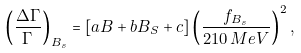Convert formula to latex. <formula><loc_0><loc_0><loc_500><loc_500>\left ( \frac { \Delta \Gamma } { \Gamma } \right ) _ { B _ { s } } = \left [ a B + b B _ { S } + c \right ] \left ( \frac { f _ { B _ { s } } } { 2 1 0 \, M e V } \right ) ^ { 2 } ,</formula> 